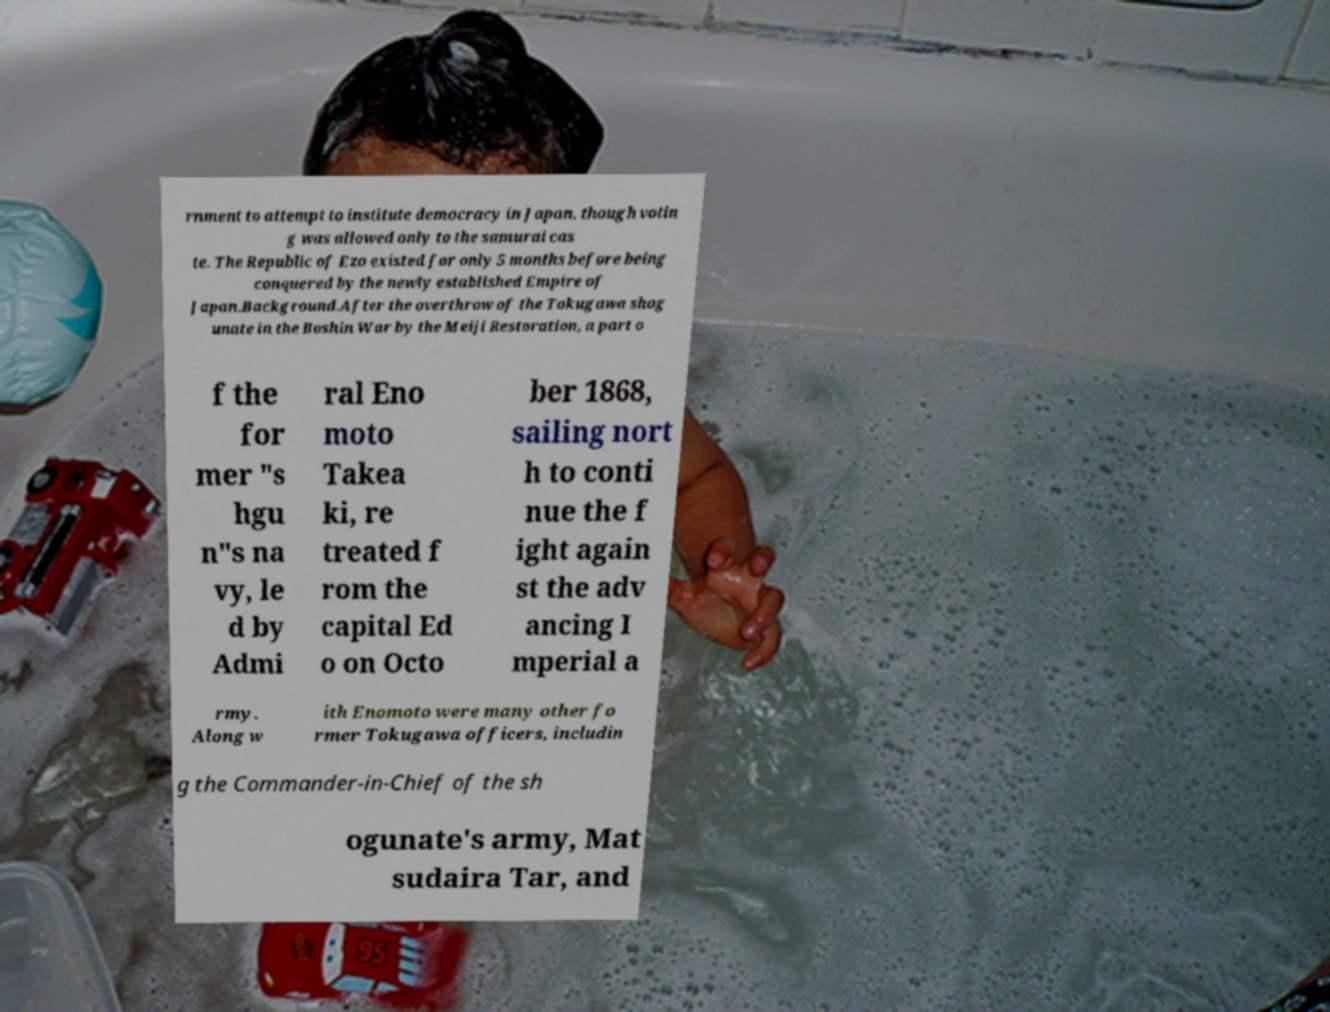I need the written content from this picture converted into text. Can you do that? rnment to attempt to institute democracy in Japan, though votin g was allowed only to the samurai cas te. The Republic of Ezo existed for only 5 months before being conquered by the newly established Empire of Japan.Background.After the overthrow of the Tokugawa shog unate in the Boshin War by the Meiji Restoration, a part o f the for mer "s hgu n"s na vy, le d by Admi ral Eno moto Takea ki, re treated f rom the capital Ed o on Octo ber 1868, sailing nort h to conti nue the f ight again st the adv ancing I mperial a rmy. Along w ith Enomoto were many other fo rmer Tokugawa officers, includin g the Commander-in-Chief of the sh ogunate's army, Mat sudaira Tar, and 